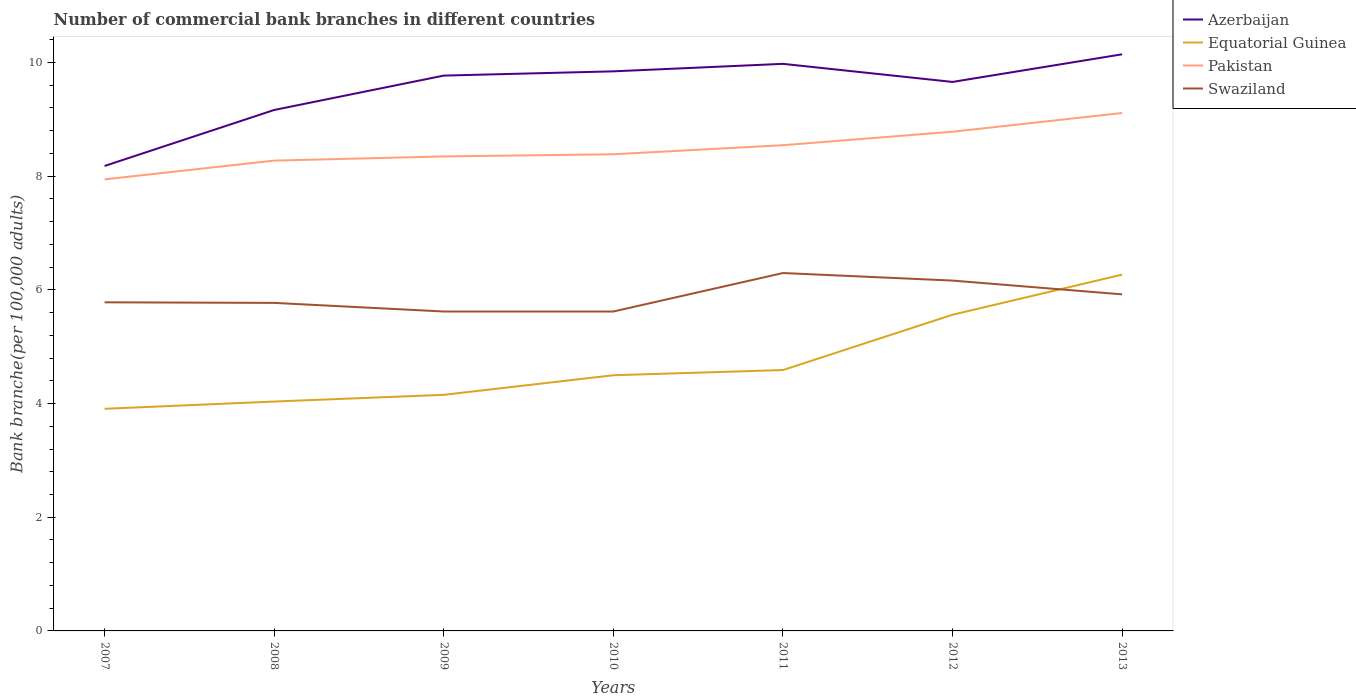Does the line corresponding to Pakistan intersect with the line corresponding to Swaziland?
Your response must be concise. No. Is the number of lines equal to the number of legend labels?
Your answer should be very brief. Yes. Across all years, what is the maximum number of commercial bank branches in Equatorial Guinea?
Ensure brevity in your answer.  3.91. What is the total number of commercial bank branches in Swaziland in the graph?
Ensure brevity in your answer.  0. What is the difference between the highest and the second highest number of commercial bank branches in Azerbaijan?
Make the answer very short. 1.96. How many lines are there?
Offer a terse response. 4. How many years are there in the graph?
Offer a terse response. 7. Does the graph contain grids?
Your answer should be very brief. No. How many legend labels are there?
Provide a succinct answer. 4. How are the legend labels stacked?
Your response must be concise. Vertical. What is the title of the graph?
Offer a very short reply. Number of commercial bank branches in different countries. What is the label or title of the Y-axis?
Your answer should be very brief. Bank branche(per 100,0 adults). What is the Bank branche(per 100,000 adults) in Azerbaijan in 2007?
Your answer should be very brief. 8.18. What is the Bank branche(per 100,000 adults) of Equatorial Guinea in 2007?
Offer a terse response. 3.91. What is the Bank branche(per 100,000 adults) of Pakistan in 2007?
Offer a very short reply. 7.94. What is the Bank branche(per 100,000 adults) of Swaziland in 2007?
Ensure brevity in your answer.  5.78. What is the Bank branche(per 100,000 adults) in Azerbaijan in 2008?
Ensure brevity in your answer.  9.16. What is the Bank branche(per 100,000 adults) of Equatorial Guinea in 2008?
Give a very brief answer. 4.03. What is the Bank branche(per 100,000 adults) of Pakistan in 2008?
Offer a very short reply. 8.27. What is the Bank branche(per 100,000 adults) in Swaziland in 2008?
Offer a very short reply. 5.77. What is the Bank branche(per 100,000 adults) in Azerbaijan in 2009?
Your response must be concise. 9.77. What is the Bank branche(per 100,000 adults) in Equatorial Guinea in 2009?
Give a very brief answer. 4.15. What is the Bank branche(per 100,000 adults) in Pakistan in 2009?
Offer a terse response. 8.35. What is the Bank branche(per 100,000 adults) of Swaziland in 2009?
Offer a very short reply. 5.62. What is the Bank branche(per 100,000 adults) in Azerbaijan in 2010?
Offer a terse response. 9.84. What is the Bank branche(per 100,000 adults) of Equatorial Guinea in 2010?
Provide a succinct answer. 4.5. What is the Bank branche(per 100,000 adults) of Pakistan in 2010?
Keep it short and to the point. 8.38. What is the Bank branche(per 100,000 adults) in Swaziland in 2010?
Offer a terse response. 5.62. What is the Bank branche(per 100,000 adults) of Azerbaijan in 2011?
Provide a succinct answer. 9.98. What is the Bank branche(per 100,000 adults) in Equatorial Guinea in 2011?
Provide a short and direct response. 4.59. What is the Bank branche(per 100,000 adults) of Pakistan in 2011?
Provide a short and direct response. 8.54. What is the Bank branche(per 100,000 adults) in Swaziland in 2011?
Your answer should be very brief. 6.3. What is the Bank branche(per 100,000 adults) of Azerbaijan in 2012?
Provide a succinct answer. 9.66. What is the Bank branche(per 100,000 adults) of Equatorial Guinea in 2012?
Provide a succinct answer. 5.56. What is the Bank branche(per 100,000 adults) of Pakistan in 2012?
Provide a short and direct response. 8.78. What is the Bank branche(per 100,000 adults) in Swaziland in 2012?
Provide a short and direct response. 6.16. What is the Bank branche(per 100,000 adults) of Azerbaijan in 2013?
Provide a short and direct response. 10.14. What is the Bank branche(per 100,000 adults) of Equatorial Guinea in 2013?
Make the answer very short. 6.27. What is the Bank branche(per 100,000 adults) in Pakistan in 2013?
Ensure brevity in your answer.  9.11. What is the Bank branche(per 100,000 adults) of Swaziland in 2013?
Offer a terse response. 5.92. Across all years, what is the maximum Bank branche(per 100,000 adults) of Azerbaijan?
Give a very brief answer. 10.14. Across all years, what is the maximum Bank branche(per 100,000 adults) of Equatorial Guinea?
Make the answer very short. 6.27. Across all years, what is the maximum Bank branche(per 100,000 adults) in Pakistan?
Give a very brief answer. 9.11. Across all years, what is the maximum Bank branche(per 100,000 adults) in Swaziland?
Your answer should be compact. 6.3. Across all years, what is the minimum Bank branche(per 100,000 adults) in Azerbaijan?
Provide a succinct answer. 8.18. Across all years, what is the minimum Bank branche(per 100,000 adults) of Equatorial Guinea?
Offer a very short reply. 3.91. Across all years, what is the minimum Bank branche(per 100,000 adults) in Pakistan?
Your answer should be very brief. 7.94. Across all years, what is the minimum Bank branche(per 100,000 adults) in Swaziland?
Your answer should be compact. 5.62. What is the total Bank branche(per 100,000 adults) in Azerbaijan in the graph?
Your response must be concise. 66.73. What is the total Bank branche(per 100,000 adults) in Equatorial Guinea in the graph?
Give a very brief answer. 33.01. What is the total Bank branche(per 100,000 adults) of Pakistan in the graph?
Make the answer very short. 59.38. What is the total Bank branche(per 100,000 adults) of Swaziland in the graph?
Give a very brief answer. 41.17. What is the difference between the Bank branche(per 100,000 adults) in Azerbaijan in 2007 and that in 2008?
Make the answer very short. -0.98. What is the difference between the Bank branche(per 100,000 adults) of Equatorial Guinea in 2007 and that in 2008?
Your answer should be compact. -0.13. What is the difference between the Bank branche(per 100,000 adults) of Pakistan in 2007 and that in 2008?
Offer a terse response. -0.33. What is the difference between the Bank branche(per 100,000 adults) of Swaziland in 2007 and that in 2008?
Make the answer very short. 0.01. What is the difference between the Bank branche(per 100,000 adults) of Azerbaijan in 2007 and that in 2009?
Your answer should be compact. -1.59. What is the difference between the Bank branche(per 100,000 adults) in Equatorial Guinea in 2007 and that in 2009?
Your response must be concise. -0.25. What is the difference between the Bank branche(per 100,000 adults) in Pakistan in 2007 and that in 2009?
Offer a terse response. -0.4. What is the difference between the Bank branche(per 100,000 adults) in Swaziland in 2007 and that in 2009?
Your response must be concise. 0.16. What is the difference between the Bank branche(per 100,000 adults) in Azerbaijan in 2007 and that in 2010?
Offer a very short reply. -1.66. What is the difference between the Bank branche(per 100,000 adults) in Equatorial Guinea in 2007 and that in 2010?
Keep it short and to the point. -0.59. What is the difference between the Bank branche(per 100,000 adults) of Pakistan in 2007 and that in 2010?
Ensure brevity in your answer.  -0.44. What is the difference between the Bank branche(per 100,000 adults) of Swaziland in 2007 and that in 2010?
Make the answer very short. 0.16. What is the difference between the Bank branche(per 100,000 adults) of Azerbaijan in 2007 and that in 2011?
Provide a short and direct response. -1.8. What is the difference between the Bank branche(per 100,000 adults) of Equatorial Guinea in 2007 and that in 2011?
Ensure brevity in your answer.  -0.68. What is the difference between the Bank branche(per 100,000 adults) in Pakistan in 2007 and that in 2011?
Provide a succinct answer. -0.6. What is the difference between the Bank branche(per 100,000 adults) of Swaziland in 2007 and that in 2011?
Keep it short and to the point. -0.52. What is the difference between the Bank branche(per 100,000 adults) of Azerbaijan in 2007 and that in 2012?
Offer a very short reply. -1.48. What is the difference between the Bank branche(per 100,000 adults) of Equatorial Guinea in 2007 and that in 2012?
Your response must be concise. -1.65. What is the difference between the Bank branche(per 100,000 adults) in Pakistan in 2007 and that in 2012?
Offer a very short reply. -0.84. What is the difference between the Bank branche(per 100,000 adults) in Swaziland in 2007 and that in 2012?
Keep it short and to the point. -0.38. What is the difference between the Bank branche(per 100,000 adults) of Azerbaijan in 2007 and that in 2013?
Your answer should be very brief. -1.96. What is the difference between the Bank branche(per 100,000 adults) in Equatorial Guinea in 2007 and that in 2013?
Provide a short and direct response. -2.36. What is the difference between the Bank branche(per 100,000 adults) in Pakistan in 2007 and that in 2013?
Your response must be concise. -1.17. What is the difference between the Bank branche(per 100,000 adults) of Swaziland in 2007 and that in 2013?
Ensure brevity in your answer.  -0.14. What is the difference between the Bank branche(per 100,000 adults) in Azerbaijan in 2008 and that in 2009?
Provide a short and direct response. -0.6. What is the difference between the Bank branche(per 100,000 adults) of Equatorial Guinea in 2008 and that in 2009?
Your answer should be compact. -0.12. What is the difference between the Bank branche(per 100,000 adults) of Pakistan in 2008 and that in 2009?
Provide a succinct answer. -0.07. What is the difference between the Bank branche(per 100,000 adults) of Swaziland in 2008 and that in 2009?
Your response must be concise. 0.15. What is the difference between the Bank branche(per 100,000 adults) of Azerbaijan in 2008 and that in 2010?
Offer a terse response. -0.68. What is the difference between the Bank branche(per 100,000 adults) in Equatorial Guinea in 2008 and that in 2010?
Keep it short and to the point. -0.46. What is the difference between the Bank branche(per 100,000 adults) in Pakistan in 2008 and that in 2010?
Your answer should be compact. -0.11. What is the difference between the Bank branche(per 100,000 adults) of Swaziland in 2008 and that in 2010?
Provide a succinct answer. 0.15. What is the difference between the Bank branche(per 100,000 adults) in Azerbaijan in 2008 and that in 2011?
Offer a terse response. -0.81. What is the difference between the Bank branche(per 100,000 adults) of Equatorial Guinea in 2008 and that in 2011?
Your answer should be compact. -0.55. What is the difference between the Bank branche(per 100,000 adults) of Pakistan in 2008 and that in 2011?
Make the answer very short. -0.27. What is the difference between the Bank branche(per 100,000 adults) of Swaziland in 2008 and that in 2011?
Offer a very short reply. -0.53. What is the difference between the Bank branche(per 100,000 adults) of Azerbaijan in 2008 and that in 2012?
Give a very brief answer. -0.49. What is the difference between the Bank branche(per 100,000 adults) in Equatorial Guinea in 2008 and that in 2012?
Keep it short and to the point. -1.53. What is the difference between the Bank branche(per 100,000 adults) of Pakistan in 2008 and that in 2012?
Give a very brief answer. -0.51. What is the difference between the Bank branche(per 100,000 adults) in Swaziland in 2008 and that in 2012?
Make the answer very short. -0.39. What is the difference between the Bank branche(per 100,000 adults) of Azerbaijan in 2008 and that in 2013?
Ensure brevity in your answer.  -0.98. What is the difference between the Bank branche(per 100,000 adults) in Equatorial Guinea in 2008 and that in 2013?
Keep it short and to the point. -2.23. What is the difference between the Bank branche(per 100,000 adults) in Pakistan in 2008 and that in 2013?
Make the answer very short. -0.84. What is the difference between the Bank branche(per 100,000 adults) of Swaziland in 2008 and that in 2013?
Provide a succinct answer. -0.15. What is the difference between the Bank branche(per 100,000 adults) in Azerbaijan in 2009 and that in 2010?
Provide a succinct answer. -0.07. What is the difference between the Bank branche(per 100,000 adults) in Equatorial Guinea in 2009 and that in 2010?
Give a very brief answer. -0.34. What is the difference between the Bank branche(per 100,000 adults) in Pakistan in 2009 and that in 2010?
Ensure brevity in your answer.  -0.04. What is the difference between the Bank branche(per 100,000 adults) of Azerbaijan in 2009 and that in 2011?
Offer a terse response. -0.21. What is the difference between the Bank branche(per 100,000 adults) of Equatorial Guinea in 2009 and that in 2011?
Give a very brief answer. -0.44. What is the difference between the Bank branche(per 100,000 adults) of Pakistan in 2009 and that in 2011?
Give a very brief answer. -0.2. What is the difference between the Bank branche(per 100,000 adults) of Swaziland in 2009 and that in 2011?
Provide a succinct answer. -0.68. What is the difference between the Bank branche(per 100,000 adults) of Azerbaijan in 2009 and that in 2012?
Make the answer very short. 0.11. What is the difference between the Bank branche(per 100,000 adults) in Equatorial Guinea in 2009 and that in 2012?
Provide a succinct answer. -1.41. What is the difference between the Bank branche(per 100,000 adults) of Pakistan in 2009 and that in 2012?
Provide a succinct answer. -0.43. What is the difference between the Bank branche(per 100,000 adults) of Swaziland in 2009 and that in 2012?
Offer a very short reply. -0.54. What is the difference between the Bank branche(per 100,000 adults) in Azerbaijan in 2009 and that in 2013?
Your answer should be compact. -0.37. What is the difference between the Bank branche(per 100,000 adults) of Equatorial Guinea in 2009 and that in 2013?
Offer a terse response. -2.11. What is the difference between the Bank branche(per 100,000 adults) of Pakistan in 2009 and that in 2013?
Give a very brief answer. -0.76. What is the difference between the Bank branche(per 100,000 adults) in Swaziland in 2009 and that in 2013?
Your response must be concise. -0.3. What is the difference between the Bank branche(per 100,000 adults) in Azerbaijan in 2010 and that in 2011?
Offer a very short reply. -0.13. What is the difference between the Bank branche(per 100,000 adults) of Equatorial Guinea in 2010 and that in 2011?
Make the answer very short. -0.09. What is the difference between the Bank branche(per 100,000 adults) of Pakistan in 2010 and that in 2011?
Your response must be concise. -0.16. What is the difference between the Bank branche(per 100,000 adults) in Swaziland in 2010 and that in 2011?
Your answer should be compact. -0.68. What is the difference between the Bank branche(per 100,000 adults) in Azerbaijan in 2010 and that in 2012?
Your answer should be compact. 0.19. What is the difference between the Bank branche(per 100,000 adults) in Equatorial Guinea in 2010 and that in 2012?
Ensure brevity in your answer.  -1.06. What is the difference between the Bank branche(per 100,000 adults) of Pakistan in 2010 and that in 2012?
Offer a very short reply. -0.4. What is the difference between the Bank branche(per 100,000 adults) of Swaziland in 2010 and that in 2012?
Keep it short and to the point. -0.54. What is the difference between the Bank branche(per 100,000 adults) of Azerbaijan in 2010 and that in 2013?
Offer a very short reply. -0.3. What is the difference between the Bank branche(per 100,000 adults) in Equatorial Guinea in 2010 and that in 2013?
Keep it short and to the point. -1.77. What is the difference between the Bank branche(per 100,000 adults) of Pakistan in 2010 and that in 2013?
Keep it short and to the point. -0.73. What is the difference between the Bank branche(per 100,000 adults) of Swaziland in 2010 and that in 2013?
Offer a very short reply. -0.3. What is the difference between the Bank branche(per 100,000 adults) of Azerbaijan in 2011 and that in 2012?
Ensure brevity in your answer.  0.32. What is the difference between the Bank branche(per 100,000 adults) in Equatorial Guinea in 2011 and that in 2012?
Keep it short and to the point. -0.97. What is the difference between the Bank branche(per 100,000 adults) in Pakistan in 2011 and that in 2012?
Your answer should be compact. -0.24. What is the difference between the Bank branche(per 100,000 adults) of Swaziland in 2011 and that in 2012?
Offer a very short reply. 0.13. What is the difference between the Bank branche(per 100,000 adults) in Azerbaijan in 2011 and that in 2013?
Ensure brevity in your answer.  -0.17. What is the difference between the Bank branche(per 100,000 adults) of Equatorial Guinea in 2011 and that in 2013?
Your response must be concise. -1.68. What is the difference between the Bank branche(per 100,000 adults) in Pakistan in 2011 and that in 2013?
Give a very brief answer. -0.57. What is the difference between the Bank branche(per 100,000 adults) of Swaziland in 2011 and that in 2013?
Your response must be concise. 0.38. What is the difference between the Bank branche(per 100,000 adults) of Azerbaijan in 2012 and that in 2013?
Your answer should be very brief. -0.49. What is the difference between the Bank branche(per 100,000 adults) of Equatorial Guinea in 2012 and that in 2013?
Provide a short and direct response. -0.71. What is the difference between the Bank branche(per 100,000 adults) of Pakistan in 2012 and that in 2013?
Provide a succinct answer. -0.33. What is the difference between the Bank branche(per 100,000 adults) of Swaziland in 2012 and that in 2013?
Provide a short and direct response. 0.24. What is the difference between the Bank branche(per 100,000 adults) in Azerbaijan in 2007 and the Bank branche(per 100,000 adults) in Equatorial Guinea in 2008?
Offer a terse response. 4.14. What is the difference between the Bank branche(per 100,000 adults) of Azerbaijan in 2007 and the Bank branche(per 100,000 adults) of Pakistan in 2008?
Make the answer very short. -0.09. What is the difference between the Bank branche(per 100,000 adults) of Azerbaijan in 2007 and the Bank branche(per 100,000 adults) of Swaziland in 2008?
Make the answer very short. 2.41. What is the difference between the Bank branche(per 100,000 adults) in Equatorial Guinea in 2007 and the Bank branche(per 100,000 adults) in Pakistan in 2008?
Your answer should be very brief. -4.37. What is the difference between the Bank branche(per 100,000 adults) in Equatorial Guinea in 2007 and the Bank branche(per 100,000 adults) in Swaziland in 2008?
Offer a terse response. -1.86. What is the difference between the Bank branche(per 100,000 adults) of Pakistan in 2007 and the Bank branche(per 100,000 adults) of Swaziland in 2008?
Offer a terse response. 2.17. What is the difference between the Bank branche(per 100,000 adults) of Azerbaijan in 2007 and the Bank branche(per 100,000 adults) of Equatorial Guinea in 2009?
Keep it short and to the point. 4.03. What is the difference between the Bank branche(per 100,000 adults) in Azerbaijan in 2007 and the Bank branche(per 100,000 adults) in Pakistan in 2009?
Your answer should be very brief. -0.17. What is the difference between the Bank branche(per 100,000 adults) of Azerbaijan in 2007 and the Bank branche(per 100,000 adults) of Swaziland in 2009?
Keep it short and to the point. 2.56. What is the difference between the Bank branche(per 100,000 adults) in Equatorial Guinea in 2007 and the Bank branche(per 100,000 adults) in Pakistan in 2009?
Your response must be concise. -4.44. What is the difference between the Bank branche(per 100,000 adults) of Equatorial Guinea in 2007 and the Bank branche(per 100,000 adults) of Swaziland in 2009?
Provide a succinct answer. -1.71. What is the difference between the Bank branche(per 100,000 adults) of Pakistan in 2007 and the Bank branche(per 100,000 adults) of Swaziland in 2009?
Provide a succinct answer. 2.32. What is the difference between the Bank branche(per 100,000 adults) in Azerbaijan in 2007 and the Bank branche(per 100,000 adults) in Equatorial Guinea in 2010?
Keep it short and to the point. 3.68. What is the difference between the Bank branche(per 100,000 adults) of Azerbaijan in 2007 and the Bank branche(per 100,000 adults) of Pakistan in 2010?
Offer a terse response. -0.21. What is the difference between the Bank branche(per 100,000 adults) of Azerbaijan in 2007 and the Bank branche(per 100,000 adults) of Swaziland in 2010?
Your response must be concise. 2.56. What is the difference between the Bank branche(per 100,000 adults) of Equatorial Guinea in 2007 and the Bank branche(per 100,000 adults) of Pakistan in 2010?
Ensure brevity in your answer.  -4.48. What is the difference between the Bank branche(per 100,000 adults) in Equatorial Guinea in 2007 and the Bank branche(per 100,000 adults) in Swaziland in 2010?
Make the answer very short. -1.71. What is the difference between the Bank branche(per 100,000 adults) in Pakistan in 2007 and the Bank branche(per 100,000 adults) in Swaziland in 2010?
Offer a very short reply. 2.32. What is the difference between the Bank branche(per 100,000 adults) of Azerbaijan in 2007 and the Bank branche(per 100,000 adults) of Equatorial Guinea in 2011?
Your answer should be compact. 3.59. What is the difference between the Bank branche(per 100,000 adults) of Azerbaijan in 2007 and the Bank branche(per 100,000 adults) of Pakistan in 2011?
Your response must be concise. -0.36. What is the difference between the Bank branche(per 100,000 adults) of Azerbaijan in 2007 and the Bank branche(per 100,000 adults) of Swaziland in 2011?
Provide a succinct answer. 1.88. What is the difference between the Bank branche(per 100,000 adults) of Equatorial Guinea in 2007 and the Bank branche(per 100,000 adults) of Pakistan in 2011?
Give a very brief answer. -4.64. What is the difference between the Bank branche(per 100,000 adults) of Equatorial Guinea in 2007 and the Bank branche(per 100,000 adults) of Swaziland in 2011?
Offer a very short reply. -2.39. What is the difference between the Bank branche(per 100,000 adults) in Pakistan in 2007 and the Bank branche(per 100,000 adults) in Swaziland in 2011?
Keep it short and to the point. 1.65. What is the difference between the Bank branche(per 100,000 adults) of Azerbaijan in 2007 and the Bank branche(per 100,000 adults) of Equatorial Guinea in 2012?
Your answer should be compact. 2.62. What is the difference between the Bank branche(per 100,000 adults) in Azerbaijan in 2007 and the Bank branche(per 100,000 adults) in Pakistan in 2012?
Provide a short and direct response. -0.6. What is the difference between the Bank branche(per 100,000 adults) in Azerbaijan in 2007 and the Bank branche(per 100,000 adults) in Swaziland in 2012?
Ensure brevity in your answer.  2.02. What is the difference between the Bank branche(per 100,000 adults) in Equatorial Guinea in 2007 and the Bank branche(per 100,000 adults) in Pakistan in 2012?
Ensure brevity in your answer.  -4.87. What is the difference between the Bank branche(per 100,000 adults) of Equatorial Guinea in 2007 and the Bank branche(per 100,000 adults) of Swaziland in 2012?
Your answer should be compact. -2.26. What is the difference between the Bank branche(per 100,000 adults) in Pakistan in 2007 and the Bank branche(per 100,000 adults) in Swaziland in 2012?
Give a very brief answer. 1.78. What is the difference between the Bank branche(per 100,000 adults) in Azerbaijan in 2007 and the Bank branche(per 100,000 adults) in Equatorial Guinea in 2013?
Give a very brief answer. 1.91. What is the difference between the Bank branche(per 100,000 adults) in Azerbaijan in 2007 and the Bank branche(per 100,000 adults) in Pakistan in 2013?
Ensure brevity in your answer.  -0.93. What is the difference between the Bank branche(per 100,000 adults) in Azerbaijan in 2007 and the Bank branche(per 100,000 adults) in Swaziland in 2013?
Give a very brief answer. 2.26. What is the difference between the Bank branche(per 100,000 adults) of Equatorial Guinea in 2007 and the Bank branche(per 100,000 adults) of Pakistan in 2013?
Your answer should be compact. -5.2. What is the difference between the Bank branche(per 100,000 adults) in Equatorial Guinea in 2007 and the Bank branche(per 100,000 adults) in Swaziland in 2013?
Give a very brief answer. -2.01. What is the difference between the Bank branche(per 100,000 adults) in Pakistan in 2007 and the Bank branche(per 100,000 adults) in Swaziland in 2013?
Your answer should be very brief. 2.02. What is the difference between the Bank branche(per 100,000 adults) of Azerbaijan in 2008 and the Bank branche(per 100,000 adults) of Equatorial Guinea in 2009?
Provide a short and direct response. 5.01. What is the difference between the Bank branche(per 100,000 adults) of Azerbaijan in 2008 and the Bank branche(per 100,000 adults) of Pakistan in 2009?
Your response must be concise. 0.82. What is the difference between the Bank branche(per 100,000 adults) of Azerbaijan in 2008 and the Bank branche(per 100,000 adults) of Swaziland in 2009?
Your response must be concise. 3.54. What is the difference between the Bank branche(per 100,000 adults) in Equatorial Guinea in 2008 and the Bank branche(per 100,000 adults) in Pakistan in 2009?
Make the answer very short. -4.31. What is the difference between the Bank branche(per 100,000 adults) of Equatorial Guinea in 2008 and the Bank branche(per 100,000 adults) of Swaziland in 2009?
Your response must be concise. -1.58. What is the difference between the Bank branche(per 100,000 adults) of Pakistan in 2008 and the Bank branche(per 100,000 adults) of Swaziland in 2009?
Offer a terse response. 2.65. What is the difference between the Bank branche(per 100,000 adults) of Azerbaijan in 2008 and the Bank branche(per 100,000 adults) of Equatorial Guinea in 2010?
Give a very brief answer. 4.67. What is the difference between the Bank branche(per 100,000 adults) of Azerbaijan in 2008 and the Bank branche(per 100,000 adults) of Pakistan in 2010?
Your answer should be very brief. 0.78. What is the difference between the Bank branche(per 100,000 adults) of Azerbaijan in 2008 and the Bank branche(per 100,000 adults) of Swaziland in 2010?
Ensure brevity in your answer.  3.55. What is the difference between the Bank branche(per 100,000 adults) in Equatorial Guinea in 2008 and the Bank branche(per 100,000 adults) in Pakistan in 2010?
Give a very brief answer. -4.35. What is the difference between the Bank branche(per 100,000 adults) in Equatorial Guinea in 2008 and the Bank branche(per 100,000 adults) in Swaziland in 2010?
Keep it short and to the point. -1.58. What is the difference between the Bank branche(per 100,000 adults) of Pakistan in 2008 and the Bank branche(per 100,000 adults) of Swaziland in 2010?
Your response must be concise. 2.65. What is the difference between the Bank branche(per 100,000 adults) in Azerbaijan in 2008 and the Bank branche(per 100,000 adults) in Equatorial Guinea in 2011?
Keep it short and to the point. 4.57. What is the difference between the Bank branche(per 100,000 adults) of Azerbaijan in 2008 and the Bank branche(per 100,000 adults) of Pakistan in 2011?
Ensure brevity in your answer.  0.62. What is the difference between the Bank branche(per 100,000 adults) of Azerbaijan in 2008 and the Bank branche(per 100,000 adults) of Swaziland in 2011?
Your response must be concise. 2.87. What is the difference between the Bank branche(per 100,000 adults) in Equatorial Guinea in 2008 and the Bank branche(per 100,000 adults) in Pakistan in 2011?
Your response must be concise. -4.51. What is the difference between the Bank branche(per 100,000 adults) in Equatorial Guinea in 2008 and the Bank branche(per 100,000 adults) in Swaziland in 2011?
Offer a very short reply. -2.26. What is the difference between the Bank branche(per 100,000 adults) of Pakistan in 2008 and the Bank branche(per 100,000 adults) of Swaziland in 2011?
Offer a terse response. 1.98. What is the difference between the Bank branche(per 100,000 adults) in Azerbaijan in 2008 and the Bank branche(per 100,000 adults) in Equatorial Guinea in 2012?
Your response must be concise. 3.6. What is the difference between the Bank branche(per 100,000 adults) of Azerbaijan in 2008 and the Bank branche(per 100,000 adults) of Pakistan in 2012?
Ensure brevity in your answer.  0.38. What is the difference between the Bank branche(per 100,000 adults) in Azerbaijan in 2008 and the Bank branche(per 100,000 adults) in Swaziland in 2012?
Provide a short and direct response. 3. What is the difference between the Bank branche(per 100,000 adults) in Equatorial Guinea in 2008 and the Bank branche(per 100,000 adults) in Pakistan in 2012?
Make the answer very short. -4.75. What is the difference between the Bank branche(per 100,000 adults) of Equatorial Guinea in 2008 and the Bank branche(per 100,000 adults) of Swaziland in 2012?
Keep it short and to the point. -2.13. What is the difference between the Bank branche(per 100,000 adults) of Pakistan in 2008 and the Bank branche(per 100,000 adults) of Swaziland in 2012?
Your answer should be compact. 2.11. What is the difference between the Bank branche(per 100,000 adults) in Azerbaijan in 2008 and the Bank branche(per 100,000 adults) in Equatorial Guinea in 2013?
Keep it short and to the point. 2.9. What is the difference between the Bank branche(per 100,000 adults) in Azerbaijan in 2008 and the Bank branche(per 100,000 adults) in Pakistan in 2013?
Your answer should be very brief. 0.05. What is the difference between the Bank branche(per 100,000 adults) in Azerbaijan in 2008 and the Bank branche(per 100,000 adults) in Swaziland in 2013?
Provide a succinct answer. 3.24. What is the difference between the Bank branche(per 100,000 adults) in Equatorial Guinea in 2008 and the Bank branche(per 100,000 adults) in Pakistan in 2013?
Provide a succinct answer. -5.08. What is the difference between the Bank branche(per 100,000 adults) in Equatorial Guinea in 2008 and the Bank branche(per 100,000 adults) in Swaziland in 2013?
Give a very brief answer. -1.89. What is the difference between the Bank branche(per 100,000 adults) in Pakistan in 2008 and the Bank branche(per 100,000 adults) in Swaziland in 2013?
Your answer should be very brief. 2.35. What is the difference between the Bank branche(per 100,000 adults) of Azerbaijan in 2009 and the Bank branche(per 100,000 adults) of Equatorial Guinea in 2010?
Offer a very short reply. 5.27. What is the difference between the Bank branche(per 100,000 adults) in Azerbaijan in 2009 and the Bank branche(per 100,000 adults) in Pakistan in 2010?
Make the answer very short. 1.38. What is the difference between the Bank branche(per 100,000 adults) of Azerbaijan in 2009 and the Bank branche(per 100,000 adults) of Swaziland in 2010?
Offer a terse response. 4.15. What is the difference between the Bank branche(per 100,000 adults) of Equatorial Guinea in 2009 and the Bank branche(per 100,000 adults) of Pakistan in 2010?
Offer a very short reply. -4.23. What is the difference between the Bank branche(per 100,000 adults) in Equatorial Guinea in 2009 and the Bank branche(per 100,000 adults) in Swaziland in 2010?
Your response must be concise. -1.47. What is the difference between the Bank branche(per 100,000 adults) in Pakistan in 2009 and the Bank branche(per 100,000 adults) in Swaziland in 2010?
Your response must be concise. 2.73. What is the difference between the Bank branche(per 100,000 adults) of Azerbaijan in 2009 and the Bank branche(per 100,000 adults) of Equatorial Guinea in 2011?
Make the answer very short. 5.18. What is the difference between the Bank branche(per 100,000 adults) in Azerbaijan in 2009 and the Bank branche(per 100,000 adults) in Pakistan in 2011?
Offer a terse response. 1.22. What is the difference between the Bank branche(per 100,000 adults) in Azerbaijan in 2009 and the Bank branche(per 100,000 adults) in Swaziland in 2011?
Your answer should be very brief. 3.47. What is the difference between the Bank branche(per 100,000 adults) of Equatorial Guinea in 2009 and the Bank branche(per 100,000 adults) of Pakistan in 2011?
Provide a short and direct response. -4.39. What is the difference between the Bank branche(per 100,000 adults) in Equatorial Guinea in 2009 and the Bank branche(per 100,000 adults) in Swaziland in 2011?
Ensure brevity in your answer.  -2.14. What is the difference between the Bank branche(per 100,000 adults) of Pakistan in 2009 and the Bank branche(per 100,000 adults) of Swaziland in 2011?
Provide a succinct answer. 2.05. What is the difference between the Bank branche(per 100,000 adults) of Azerbaijan in 2009 and the Bank branche(per 100,000 adults) of Equatorial Guinea in 2012?
Your answer should be very brief. 4.21. What is the difference between the Bank branche(per 100,000 adults) in Azerbaijan in 2009 and the Bank branche(per 100,000 adults) in Pakistan in 2012?
Offer a terse response. 0.99. What is the difference between the Bank branche(per 100,000 adults) of Azerbaijan in 2009 and the Bank branche(per 100,000 adults) of Swaziland in 2012?
Keep it short and to the point. 3.61. What is the difference between the Bank branche(per 100,000 adults) of Equatorial Guinea in 2009 and the Bank branche(per 100,000 adults) of Pakistan in 2012?
Keep it short and to the point. -4.63. What is the difference between the Bank branche(per 100,000 adults) in Equatorial Guinea in 2009 and the Bank branche(per 100,000 adults) in Swaziland in 2012?
Provide a succinct answer. -2.01. What is the difference between the Bank branche(per 100,000 adults) in Pakistan in 2009 and the Bank branche(per 100,000 adults) in Swaziland in 2012?
Your answer should be very brief. 2.18. What is the difference between the Bank branche(per 100,000 adults) of Azerbaijan in 2009 and the Bank branche(per 100,000 adults) of Equatorial Guinea in 2013?
Your answer should be very brief. 3.5. What is the difference between the Bank branche(per 100,000 adults) in Azerbaijan in 2009 and the Bank branche(per 100,000 adults) in Pakistan in 2013?
Ensure brevity in your answer.  0.66. What is the difference between the Bank branche(per 100,000 adults) in Azerbaijan in 2009 and the Bank branche(per 100,000 adults) in Swaziland in 2013?
Provide a short and direct response. 3.85. What is the difference between the Bank branche(per 100,000 adults) of Equatorial Guinea in 2009 and the Bank branche(per 100,000 adults) of Pakistan in 2013?
Provide a short and direct response. -4.96. What is the difference between the Bank branche(per 100,000 adults) of Equatorial Guinea in 2009 and the Bank branche(per 100,000 adults) of Swaziland in 2013?
Your answer should be compact. -1.77. What is the difference between the Bank branche(per 100,000 adults) of Pakistan in 2009 and the Bank branche(per 100,000 adults) of Swaziland in 2013?
Your answer should be compact. 2.43. What is the difference between the Bank branche(per 100,000 adults) in Azerbaijan in 2010 and the Bank branche(per 100,000 adults) in Equatorial Guinea in 2011?
Make the answer very short. 5.25. What is the difference between the Bank branche(per 100,000 adults) of Azerbaijan in 2010 and the Bank branche(per 100,000 adults) of Pakistan in 2011?
Provide a succinct answer. 1.3. What is the difference between the Bank branche(per 100,000 adults) of Azerbaijan in 2010 and the Bank branche(per 100,000 adults) of Swaziland in 2011?
Give a very brief answer. 3.55. What is the difference between the Bank branche(per 100,000 adults) of Equatorial Guinea in 2010 and the Bank branche(per 100,000 adults) of Pakistan in 2011?
Your answer should be very brief. -4.05. What is the difference between the Bank branche(per 100,000 adults) in Equatorial Guinea in 2010 and the Bank branche(per 100,000 adults) in Swaziland in 2011?
Your answer should be compact. -1.8. What is the difference between the Bank branche(per 100,000 adults) of Pakistan in 2010 and the Bank branche(per 100,000 adults) of Swaziland in 2011?
Keep it short and to the point. 2.09. What is the difference between the Bank branche(per 100,000 adults) in Azerbaijan in 2010 and the Bank branche(per 100,000 adults) in Equatorial Guinea in 2012?
Your answer should be compact. 4.28. What is the difference between the Bank branche(per 100,000 adults) of Azerbaijan in 2010 and the Bank branche(per 100,000 adults) of Pakistan in 2012?
Provide a short and direct response. 1.06. What is the difference between the Bank branche(per 100,000 adults) of Azerbaijan in 2010 and the Bank branche(per 100,000 adults) of Swaziland in 2012?
Make the answer very short. 3.68. What is the difference between the Bank branche(per 100,000 adults) of Equatorial Guinea in 2010 and the Bank branche(per 100,000 adults) of Pakistan in 2012?
Your response must be concise. -4.28. What is the difference between the Bank branche(per 100,000 adults) of Equatorial Guinea in 2010 and the Bank branche(per 100,000 adults) of Swaziland in 2012?
Provide a short and direct response. -1.67. What is the difference between the Bank branche(per 100,000 adults) in Pakistan in 2010 and the Bank branche(per 100,000 adults) in Swaziland in 2012?
Offer a terse response. 2.22. What is the difference between the Bank branche(per 100,000 adults) in Azerbaijan in 2010 and the Bank branche(per 100,000 adults) in Equatorial Guinea in 2013?
Offer a very short reply. 3.58. What is the difference between the Bank branche(per 100,000 adults) of Azerbaijan in 2010 and the Bank branche(per 100,000 adults) of Pakistan in 2013?
Provide a short and direct response. 0.73. What is the difference between the Bank branche(per 100,000 adults) in Azerbaijan in 2010 and the Bank branche(per 100,000 adults) in Swaziland in 2013?
Your answer should be very brief. 3.92. What is the difference between the Bank branche(per 100,000 adults) in Equatorial Guinea in 2010 and the Bank branche(per 100,000 adults) in Pakistan in 2013?
Provide a succinct answer. -4.61. What is the difference between the Bank branche(per 100,000 adults) of Equatorial Guinea in 2010 and the Bank branche(per 100,000 adults) of Swaziland in 2013?
Offer a very short reply. -1.42. What is the difference between the Bank branche(per 100,000 adults) of Pakistan in 2010 and the Bank branche(per 100,000 adults) of Swaziland in 2013?
Your response must be concise. 2.46. What is the difference between the Bank branche(per 100,000 adults) of Azerbaijan in 2011 and the Bank branche(per 100,000 adults) of Equatorial Guinea in 2012?
Ensure brevity in your answer.  4.41. What is the difference between the Bank branche(per 100,000 adults) of Azerbaijan in 2011 and the Bank branche(per 100,000 adults) of Pakistan in 2012?
Provide a succinct answer. 1.19. What is the difference between the Bank branche(per 100,000 adults) in Azerbaijan in 2011 and the Bank branche(per 100,000 adults) in Swaziland in 2012?
Make the answer very short. 3.81. What is the difference between the Bank branche(per 100,000 adults) in Equatorial Guinea in 2011 and the Bank branche(per 100,000 adults) in Pakistan in 2012?
Make the answer very short. -4.19. What is the difference between the Bank branche(per 100,000 adults) of Equatorial Guinea in 2011 and the Bank branche(per 100,000 adults) of Swaziland in 2012?
Provide a short and direct response. -1.57. What is the difference between the Bank branche(per 100,000 adults) of Pakistan in 2011 and the Bank branche(per 100,000 adults) of Swaziland in 2012?
Provide a succinct answer. 2.38. What is the difference between the Bank branche(per 100,000 adults) in Azerbaijan in 2011 and the Bank branche(per 100,000 adults) in Equatorial Guinea in 2013?
Keep it short and to the point. 3.71. What is the difference between the Bank branche(per 100,000 adults) in Azerbaijan in 2011 and the Bank branche(per 100,000 adults) in Pakistan in 2013?
Offer a terse response. 0.86. What is the difference between the Bank branche(per 100,000 adults) of Azerbaijan in 2011 and the Bank branche(per 100,000 adults) of Swaziland in 2013?
Offer a terse response. 4.05. What is the difference between the Bank branche(per 100,000 adults) in Equatorial Guinea in 2011 and the Bank branche(per 100,000 adults) in Pakistan in 2013?
Provide a short and direct response. -4.52. What is the difference between the Bank branche(per 100,000 adults) of Equatorial Guinea in 2011 and the Bank branche(per 100,000 adults) of Swaziland in 2013?
Your answer should be compact. -1.33. What is the difference between the Bank branche(per 100,000 adults) in Pakistan in 2011 and the Bank branche(per 100,000 adults) in Swaziland in 2013?
Make the answer very short. 2.62. What is the difference between the Bank branche(per 100,000 adults) of Azerbaijan in 2012 and the Bank branche(per 100,000 adults) of Equatorial Guinea in 2013?
Your response must be concise. 3.39. What is the difference between the Bank branche(per 100,000 adults) of Azerbaijan in 2012 and the Bank branche(per 100,000 adults) of Pakistan in 2013?
Provide a short and direct response. 0.55. What is the difference between the Bank branche(per 100,000 adults) of Azerbaijan in 2012 and the Bank branche(per 100,000 adults) of Swaziland in 2013?
Make the answer very short. 3.74. What is the difference between the Bank branche(per 100,000 adults) of Equatorial Guinea in 2012 and the Bank branche(per 100,000 adults) of Pakistan in 2013?
Your response must be concise. -3.55. What is the difference between the Bank branche(per 100,000 adults) of Equatorial Guinea in 2012 and the Bank branche(per 100,000 adults) of Swaziland in 2013?
Your answer should be compact. -0.36. What is the difference between the Bank branche(per 100,000 adults) in Pakistan in 2012 and the Bank branche(per 100,000 adults) in Swaziland in 2013?
Ensure brevity in your answer.  2.86. What is the average Bank branche(per 100,000 adults) in Azerbaijan per year?
Provide a short and direct response. 9.53. What is the average Bank branche(per 100,000 adults) of Equatorial Guinea per year?
Make the answer very short. 4.72. What is the average Bank branche(per 100,000 adults) of Pakistan per year?
Give a very brief answer. 8.48. What is the average Bank branche(per 100,000 adults) in Swaziland per year?
Give a very brief answer. 5.88. In the year 2007, what is the difference between the Bank branche(per 100,000 adults) of Azerbaijan and Bank branche(per 100,000 adults) of Equatorial Guinea?
Give a very brief answer. 4.27. In the year 2007, what is the difference between the Bank branche(per 100,000 adults) of Azerbaijan and Bank branche(per 100,000 adults) of Pakistan?
Offer a very short reply. 0.24. In the year 2007, what is the difference between the Bank branche(per 100,000 adults) of Azerbaijan and Bank branche(per 100,000 adults) of Swaziland?
Your response must be concise. 2.4. In the year 2007, what is the difference between the Bank branche(per 100,000 adults) of Equatorial Guinea and Bank branche(per 100,000 adults) of Pakistan?
Give a very brief answer. -4.04. In the year 2007, what is the difference between the Bank branche(per 100,000 adults) in Equatorial Guinea and Bank branche(per 100,000 adults) in Swaziland?
Offer a terse response. -1.87. In the year 2007, what is the difference between the Bank branche(per 100,000 adults) of Pakistan and Bank branche(per 100,000 adults) of Swaziland?
Give a very brief answer. 2.16. In the year 2008, what is the difference between the Bank branche(per 100,000 adults) in Azerbaijan and Bank branche(per 100,000 adults) in Equatorial Guinea?
Provide a short and direct response. 5.13. In the year 2008, what is the difference between the Bank branche(per 100,000 adults) of Azerbaijan and Bank branche(per 100,000 adults) of Pakistan?
Offer a terse response. 0.89. In the year 2008, what is the difference between the Bank branche(per 100,000 adults) of Azerbaijan and Bank branche(per 100,000 adults) of Swaziland?
Ensure brevity in your answer.  3.39. In the year 2008, what is the difference between the Bank branche(per 100,000 adults) of Equatorial Guinea and Bank branche(per 100,000 adults) of Pakistan?
Give a very brief answer. -4.24. In the year 2008, what is the difference between the Bank branche(per 100,000 adults) of Equatorial Guinea and Bank branche(per 100,000 adults) of Swaziland?
Offer a very short reply. -1.74. In the year 2008, what is the difference between the Bank branche(per 100,000 adults) in Pakistan and Bank branche(per 100,000 adults) in Swaziland?
Offer a terse response. 2.5. In the year 2009, what is the difference between the Bank branche(per 100,000 adults) in Azerbaijan and Bank branche(per 100,000 adults) in Equatorial Guinea?
Your answer should be compact. 5.62. In the year 2009, what is the difference between the Bank branche(per 100,000 adults) in Azerbaijan and Bank branche(per 100,000 adults) in Pakistan?
Your response must be concise. 1.42. In the year 2009, what is the difference between the Bank branche(per 100,000 adults) in Azerbaijan and Bank branche(per 100,000 adults) in Swaziland?
Your answer should be compact. 4.15. In the year 2009, what is the difference between the Bank branche(per 100,000 adults) of Equatorial Guinea and Bank branche(per 100,000 adults) of Pakistan?
Give a very brief answer. -4.19. In the year 2009, what is the difference between the Bank branche(per 100,000 adults) in Equatorial Guinea and Bank branche(per 100,000 adults) in Swaziland?
Provide a succinct answer. -1.47. In the year 2009, what is the difference between the Bank branche(per 100,000 adults) in Pakistan and Bank branche(per 100,000 adults) in Swaziland?
Ensure brevity in your answer.  2.73. In the year 2010, what is the difference between the Bank branche(per 100,000 adults) in Azerbaijan and Bank branche(per 100,000 adults) in Equatorial Guinea?
Ensure brevity in your answer.  5.35. In the year 2010, what is the difference between the Bank branche(per 100,000 adults) in Azerbaijan and Bank branche(per 100,000 adults) in Pakistan?
Keep it short and to the point. 1.46. In the year 2010, what is the difference between the Bank branche(per 100,000 adults) of Azerbaijan and Bank branche(per 100,000 adults) of Swaziland?
Ensure brevity in your answer.  4.22. In the year 2010, what is the difference between the Bank branche(per 100,000 adults) of Equatorial Guinea and Bank branche(per 100,000 adults) of Pakistan?
Give a very brief answer. -3.89. In the year 2010, what is the difference between the Bank branche(per 100,000 adults) of Equatorial Guinea and Bank branche(per 100,000 adults) of Swaziland?
Your response must be concise. -1.12. In the year 2010, what is the difference between the Bank branche(per 100,000 adults) of Pakistan and Bank branche(per 100,000 adults) of Swaziland?
Your answer should be compact. 2.77. In the year 2011, what is the difference between the Bank branche(per 100,000 adults) in Azerbaijan and Bank branche(per 100,000 adults) in Equatorial Guinea?
Your response must be concise. 5.39. In the year 2011, what is the difference between the Bank branche(per 100,000 adults) of Azerbaijan and Bank branche(per 100,000 adults) of Pakistan?
Ensure brevity in your answer.  1.43. In the year 2011, what is the difference between the Bank branche(per 100,000 adults) in Azerbaijan and Bank branche(per 100,000 adults) in Swaziland?
Provide a short and direct response. 3.68. In the year 2011, what is the difference between the Bank branche(per 100,000 adults) of Equatorial Guinea and Bank branche(per 100,000 adults) of Pakistan?
Your answer should be very brief. -3.96. In the year 2011, what is the difference between the Bank branche(per 100,000 adults) in Equatorial Guinea and Bank branche(per 100,000 adults) in Swaziland?
Make the answer very short. -1.71. In the year 2011, what is the difference between the Bank branche(per 100,000 adults) in Pakistan and Bank branche(per 100,000 adults) in Swaziland?
Give a very brief answer. 2.25. In the year 2012, what is the difference between the Bank branche(per 100,000 adults) of Azerbaijan and Bank branche(per 100,000 adults) of Equatorial Guinea?
Keep it short and to the point. 4.1. In the year 2012, what is the difference between the Bank branche(per 100,000 adults) of Azerbaijan and Bank branche(per 100,000 adults) of Pakistan?
Provide a short and direct response. 0.88. In the year 2012, what is the difference between the Bank branche(per 100,000 adults) of Azerbaijan and Bank branche(per 100,000 adults) of Swaziland?
Keep it short and to the point. 3.49. In the year 2012, what is the difference between the Bank branche(per 100,000 adults) in Equatorial Guinea and Bank branche(per 100,000 adults) in Pakistan?
Your response must be concise. -3.22. In the year 2012, what is the difference between the Bank branche(per 100,000 adults) in Equatorial Guinea and Bank branche(per 100,000 adults) in Swaziland?
Your answer should be compact. -0.6. In the year 2012, what is the difference between the Bank branche(per 100,000 adults) in Pakistan and Bank branche(per 100,000 adults) in Swaziland?
Offer a terse response. 2.62. In the year 2013, what is the difference between the Bank branche(per 100,000 adults) of Azerbaijan and Bank branche(per 100,000 adults) of Equatorial Guinea?
Provide a succinct answer. 3.88. In the year 2013, what is the difference between the Bank branche(per 100,000 adults) of Azerbaijan and Bank branche(per 100,000 adults) of Pakistan?
Your answer should be compact. 1.03. In the year 2013, what is the difference between the Bank branche(per 100,000 adults) in Azerbaijan and Bank branche(per 100,000 adults) in Swaziland?
Offer a very short reply. 4.22. In the year 2013, what is the difference between the Bank branche(per 100,000 adults) in Equatorial Guinea and Bank branche(per 100,000 adults) in Pakistan?
Offer a very short reply. -2.84. In the year 2013, what is the difference between the Bank branche(per 100,000 adults) of Equatorial Guinea and Bank branche(per 100,000 adults) of Swaziland?
Keep it short and to the point. 0.35. In the year 2013, what is the difference between the Bank branche(per 100,000 adults) in Pakistan and Bank branche(per 100,000 adults) in Swaziland?
Your answer should be very brief. 3.19. What is the ratio of the Bank branche(per 100,000 adults) in Azerbaijan in 2007 to that in 2008?
Keep it short and to the point. 0.89. What is the ratio of the Bank branche(per 100,000 adults) in Equatorial Guinea in 2007 to that in 2008?
Your answer should be compact. 0.97. What is the ratio of the Bank branche(per 100,000 adults) in Pakistan in 2007 to that in 2008?
Your answer should be very brief. 0.96. What is the ratio of the Bank branche(per 100,000 adults) in Swaziland in 2007 to that in 2008?
Provide a short and direct response. 1. What is the ratio of the Bank branche(per 100,000 adults) in Azerbaijan in 2007 to that in 2009?
Make the answer very short. 0.84. What is the ratio of the Bank branche(per 100,000 adults) of Equatorial Guinea in 2007 to that in 2009?
Your response must be concise. 0.94. What is the ratio of the Bank branche(per 100,000 adults) of Pakistan in 2007 to that in 2009?
Offer a very short reply. 0.95. What is the ratio of the Bank branche(per 100,000 adults) of Swaziland in 2007 to that in 2009?
Provide a succinct answer. 1.03. What is the ratio of the Bank branche(per 100,000 adults) of Azerbaijan in 2007 to that in 2010?
Provide a short and direct response. 0.83. What is the ratio of the Bank branche(per 100,000 adults) of Equatorial Guinea in 2007 to that in 2010?
Your answer should be very brief. 0.87. What is the ratio of the Bank branche(per 100,000 adults) of Pakistan in 2007 to that in 2010?
Offer a terse response. 0.95. What is the ratio of the Bank branche(per 100,000 adults) in Swaziland in 2007 to that in 2010?
Offer a terse response. 1.03. What is the ratio of the Bank branche(per 100,000 adults) of Azerbaijan in 2007 to that in 2011?
Ensure brevity in your answer.  0.82. What is the ratio of the Bank branche(per 100,000 adults) in Equatorial Guinea in 2007 to that in 2011?
Provide a short and direct response. 0.85. What is the ratio of the Bank branche(per 100,000 adults) in Pakistan in 2007 to that in 2011?
Keep it short and to the point. 0.93. What is the ratio of the Bank branche(per 100,000 adults) of Swaziland in 2007 to that in 2011?
Keep it short and to the point. 0.92. What is the ratio of the Bank branche(per 100,000 adults) in Azerbaijan in 2007 to that in 2012?
Ensure brevity in your answer.  0.85. What is the ratio of the Bank branche(per 100,000 adults) of Equatorial Guinea in 2007 to that in 2012?
Your response must be concise. 0.7. What is the ratio of the Bank branche(per 100,000 adults) of Pakistan in 2007 to that in 2012?
Your answer should be compact. 0.9. What is the ratio of the Bank branche(per 100,000 adults) in Swaziland in 2007 to that in 2012?
Give a very brief answer. 0.94. What is the ratio of the Bank branche(per 100,000 adults) of Azerbaijan in 2007 to that in 2013?
Your answer should be compact. 0.81. What is the ratio of the Bank branche(per 100,000 adults) of Equatorial Guinea in 2007 to that in 2013?
Provide a succinct answer. 0.62. What is the ratio of the Bank branche(per 100,000 adults) in Pakistan in 2007 to that in 2013?
Your response must be concise. 0.87. What is the ratio of the Bank branche(per 100,000 adults) of Swaziland in 2007 to that in 2013?
Your response must be concise. 0.98. What is the ratio of the Bank branche(per 100,000 adults) in Azerbaijan in 2008 to that in 2009?
Make the answer very short. 0.94. What is the ratio of the Bank branche(per 100,000 adults) of Equatorial Guinea in 2008 to that in 2009?
Give a very brief answer. 0.97. What is the ratio of the Bank branche(per 100,000 adults) of Swaziland in 2008 to that in 2009?
Your answer should be compact. 1.03. What is the ratio of the Bank branche(per 100,000 adults) in Equatorial Guinea in 2008 to that in 2010?
Provide a succinct answer. 0.9. What is the ratio of the Bank branche(per 100,000 adults) of Pakistan in 2008 to that in 2010?
Offer a very short reply. 0.99. What is the ratio of the Bank branche(per 100,000 adults) of Swaziland in 2008 to that in 2010?
Your response must be concise. 1.03. What is the ratio of the Bank branche(per 100,000 adults) in Azerbaijan in 2008 to that in 2011?
Give a very brief answer. 0.92. What is the ratio of the Bank branche(per 100,000 adults) of Equatorial Guinea in 2008 to that in 2011?
Provide a succinct answer. 0.88. What is the ratio of the Bank branche(per 100,000 adults) in Pakistan in 2008 to that in 2011?
Your answer should be compact. 0.97. What is the ratio of the Bank branche(per 100,000 adults) in Swaziland in 2008 to that in 2011?
Ensure brevity in your answer.  0.92. What is the ratio of the Bank branche(per 100,000 adults) of Azerbaijan in 2008 to that in 2012?
Offer a terse response. 0.95. What is the ratio of the Bank branche(per 100,000 adults) in Equatorial Guinea in 2008 to that in 2012?
Keep it short and to the point. 0.73. What is the ratio of the Bank branche(per 100,000 adults) of Pakistan in 2008 to that in 2012?
Your answer should be very brief. 0.94. What is the ratio of the Bank branche(per 100,000 adults) in Swaziland in 2008 to that in 2012?
Your response must be concise. 0.94. What is the ratio of the Bank branche(per 100,000 adults) in Azerbaijan in 2008 to that in 2013?
Your answer should be compact. 0.9. What is the ratio of the Bank branche(per 100,000 adults) of Equatorial Guinea in 2008 to that in 2013?
Make the answer very short. 0.64. What is the ratio of the Bank branche(per 100,000 adults) in Pakistan in 2008 to that in 2013?
Your response must be concise. 0.91. What is the ratio of the Bank branche(per 100,000 adults) of Swaziland in 2008 to that in 2013?
Offer a terse response. 0.97. What is the ratio of the Bank branche(per 100,000 adults) of Azerbaijan in 2009 to that in 2010?
Keep it short and to the point. 0.99. What is the ratio of the Bank branche(per 100,000 adults) in Equatorial Guinea in 2009 to that in 2010?
Your answer should be compact. 0.92. What is the ratio of the Bank branche(per 100,000 adults) in Azerbaijan in 2009 to that in 2011?
Provide a succinct answer. 0.98. What is the ratio of the Bank branche(per 100,000 adults) in Equatorial Guinea in 2009 to that in 2011?
Your response must be concise. 0.91. What is the ratio of the Bank branche(per 100,000 adults) in Pakistan in 2009 to that in 2011?
Your answer should be very brief. 0.98. What is the ratio of the Bank branche(per 100,000 adults) of Swaziland in 2009 to that in 2011?
Keep it short and to the point. 0.89. What is the ratio of the Bank branche(per 100,000 adults) in Azerbaijan in 2009 to that in 2012?
Provide a succinct answer. 1.01. What is the ratio of the Bank branche(per 100,000 adults) of Equatorial Guinea in 2009 to that in 2012?
Provide a succinct answer. 0.75. What is the ratio of the Bank branche(per 100,000 adults) in Pakistan in 2009 to that in 2012?
Offer a very short reply. 0.95. What is the ratio of the Bank branche(per 100,000 adults) of Swaziland in 2009 to that in 2012?
Offer a terse response. 0.91. What is the ratio of the Bank branche(per 100,000 adults) in Azerbaijan in 2009 to that in 2013?
Keep it short and to the point. 0.96. What is the ratio of the Bank branche(per 100,000 adults) of Equatorial Guinea in 2009 to that in 2013?
Make the answer very short. 0.66. What is the ratio of the Bank branche(per 100,000 adults) in Pakistan in 2009 to that in 2013?
Offer a very short reply. 0.92. What is the ratio of the Bank branche(per 100,000 adults) in Swaziland in 2009 to that in 2013?
Keep it short and to the point. 0.95. What is the ratio of the Bank branche(per 100,000 adults) in Equatorial Guinea in 2010 to that in 2011?
Your response must be concise. 0.98. What is the ratio of the Bank branche(per 100,000 adults) in Pakistan in 2010 to that in 2011?
Offer a very short reply. 0.98. What is the ratio of the Bank branche(per 100,000 adults) in Swaziland in 2010 to that in 2011?
Your response must be concise. 0.89. What is the ratio of the Bank branche(per 100,000 adults) in Azerbaijan in 2010 to that in 2012?
Offer a very short reply. 1.02. What is the ratio of the Bank branche(per 100,000 adults) in Equatorial Guinea in 2010 to that in 2012?
Offer a terse response. 0.81. What is the ratio of the Bank branche(per 100,000 adults) in Pakistan in 2010 to that in 2012?
Your answer should be very brief. 0.95. What is the ratio of the Bank branche(per 100,000 adults) in Swaziland in 2010 to that in 2012?
Your answer should be compact. 0.91. What is the ratio of the Bank branche(per 100,000 adults) of Azerbaijan in 2010 to that in 2013?
Your answer should be compact. 0.97. What is the ratio of the Bank branche(per 100,000 adults) of Equatorial Guinea in 2010 to that in 2013?
Your answer should be compact. 0.72. What is the ratio of the Bank branche(per 100,000 adults) of Pakistan in 2010 to that in 2013?
Provide a short and direct response. 0.92. What is the ratio of the Bank branche(per 100,000 adults) in Swaziland in 2010 to that in 2013?
Your response must be concise. 0.95. What is the ratio of the Bank branche(per 100,000 adults) in Azerbaijan in 2011 to that in 2012?
Ensure brevity in your answer.  1.03. What is the ratio of the Bank branche(per 100,000 adults) in Equatorial Guinea in 2011 to that in 2012?
Give a very brief answer. 0.83. What is the ratio of the Bank branche(per 100,000 adults) of Swaziland in 2011 to that in 2012?
Provide a short and direct response. 1.02. What is the ratio of the Bank branche(per 100,000 adults) of Azerbaijan in 2011 to that in 2013?
Give a very brief answer. 0.98. What is the ratio of the Bank branche(per 100,000 adults) in Equatorial Guinea in 2011 to that in 2013?
Provide a succinct answer. 0.73. What is the ratio of the Bank branche(per 100,000 adults) in Pakistan in 2011 to that in 2013?
Make the answer very short. 0.94. What is the ratio of the Bank branche(per 100,000 adults) in Swaziland in 2011 to that in 2013?
Make the answer very short. 1.06. What is the ratio of the Bank branche(per 100,000 adults) of Azerbaijan in 2012 to that in 2013?
Provide a short and direct response. 0.95. What is the ratio of the Bank branche(per 100,000 adults) in Equatorial Guinea in 2012 to that in 2013?
Your answer should be compact. 0.89. What is the ratio of the Bank branche(per 100,000 adults) in Pakistan in 2012 to that in 2013?
Give a very brief answer. 0.96. What is the ratio of the Bank branche(per 100,000 adults) in Swaziland in 2012 to that in 2013?
Keep it short and to the point. 1.04. What is the difference between the highest and the second highest Bank branche(per 100,000 adults) in Azerbaijan?
Your response must be concise. 0.17. What is the difference between the highest and the second highest Bank branche(per 100,000 adults) in Equatorial Guinea?
Offer a terse response. 0.71. What is the difference between the highest and the second highest Bank branche(per 100,000 adults) of Pakistan?
Give a very brief answer. 0.33. What is the difference between the highest and the second highest Bank branche(per 100,000 adults) in Swaziland?
Ensure brevity in your answer.  0.13. What is the difference between the highest and the lowest Bank branche(per 100,000 adults) in Azerbaijan?
Offer a very short reply. 1.96. What is the difference between the highest and the lowest Bank branche(per 100,000 adults) of Equatorial Guinea?
Provide a succinct answer. 2.36. What is the difference between the highest and the lowest Bank branche(per 100,000 adults) of Pakistan?
Offer a terse response. 1.17. What is the difference between the highest and the lowest Bank branche(per 100,000 adults) in Swaziland?
Your response must be concise. 0.68. 